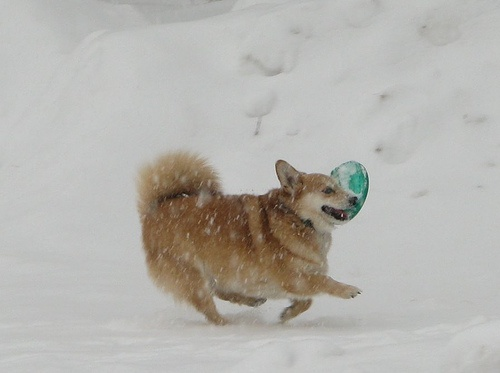Describe the objects in this image and their specific colors. I can see dog in lightgray, gray, and brown tones and frisbee in lightgray, darkgray, and teal tones in this image. 